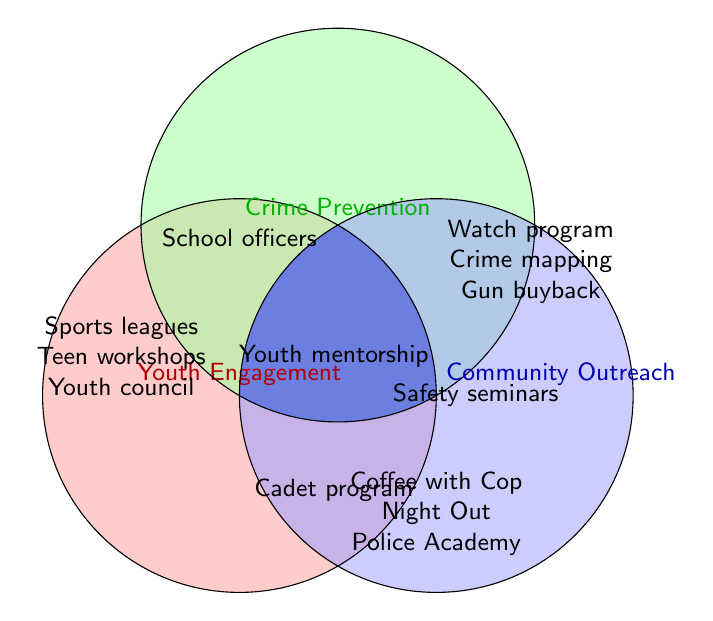Which programs are exclusively part of Youth Engagement? The programs exclusive to Youth Engagement are those that only appear in that section of the Venn Diagram. In this case, they are listed inside the red circle without overlapping other sections.
Answer: After-school sports leagues, Teen leadership workshops, Youth advisory council What are the initiatives shared by Youth Engagement and Crime Prevention? The initiatives shared by Youth Engagement and Crime Prevention are located in the overlapping area of the red and green circles.
Answer: School resource officers How many total initiatives does Community Outreach have? To find the total initiatives under Community Outreach, we need to count all entries within the blue circle, including those that overlap with other circles. These include the exclusive initiatives and the shared initiatives.
Answer: 7 Which programs are common to all three categories? The programs common to all three categories (Youth Engagement, Crime Prevention, and Community Outreach) are located at the very center where all three circles overlap.
Answer: Youth mentorship program Compare the number of exclusive initiatives between Crime Prevention and Youth Engagement. Which has more exclusive initiatives? Exclusive initiatives are those that do not overlap with other circles. By counting the initiatives in each exclusive section: Youth Engagement (3), Crime Prevention (3). Since both have an equal number, neither has more exclusive initiatives.
Answer: Neither; they are equal Which programs fall into the overlap between Crime Prevention and Community Outreach but are not part of Youth Engagement? These programs are located in the overlapping area of the green and blue circles but outside the red circle.
Answer: Community safety seminars What is the combined number of programs shared between Youth Engagement and Community Outreach (but not including Crime Prevention)? The programs shared between Youth Engagement and Community Outreach but not overlapping with Crime Prevention are located where the red and blue circles overlap, excluding the overlap with the green circle.
Answer: Police cadet program Identify the context of "Coffee with a Cop." Which category or categories does it belong to? "Coffee with a Cop" is placed within the blue circle exclusively for Community Outreach.
Answer: Community Outreach 